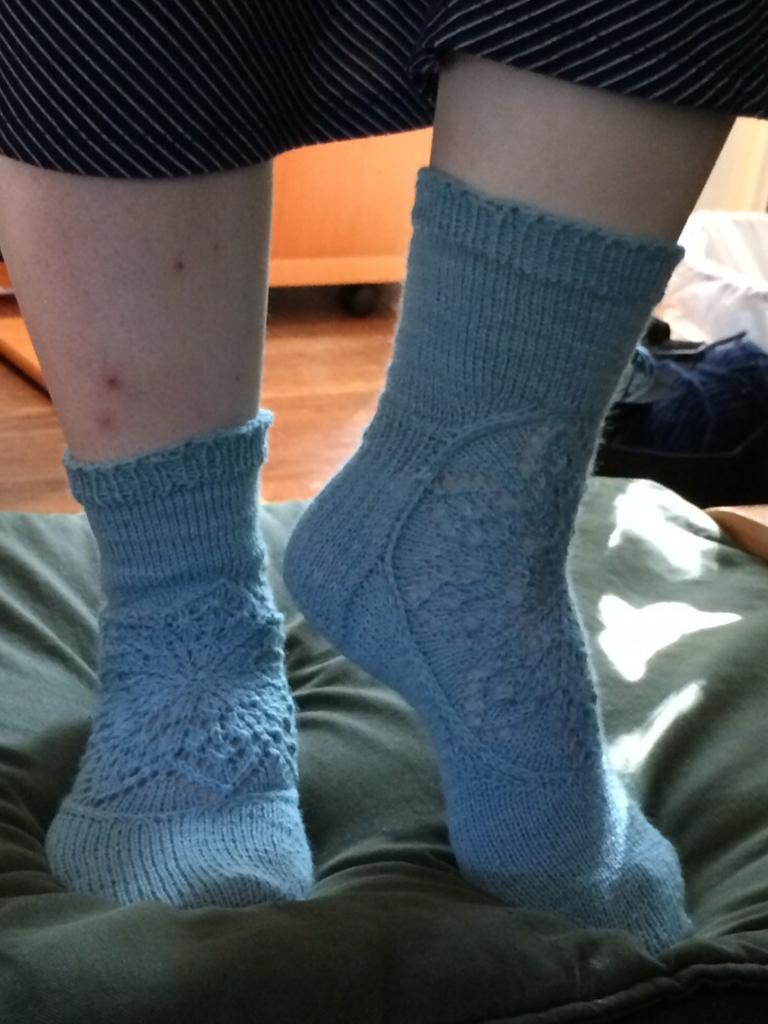What body part is visible in the image? There are a person's legs with socks in the image. What else can be seen in the background of the image? There are clothes and a wooden object visible in the background of the image. What type of surface is visible in the image? There is a floor visible in the image. What type of songs can be heard in the background of the image? There is no audio or indication of songs in the image; it only contains visual elements. 